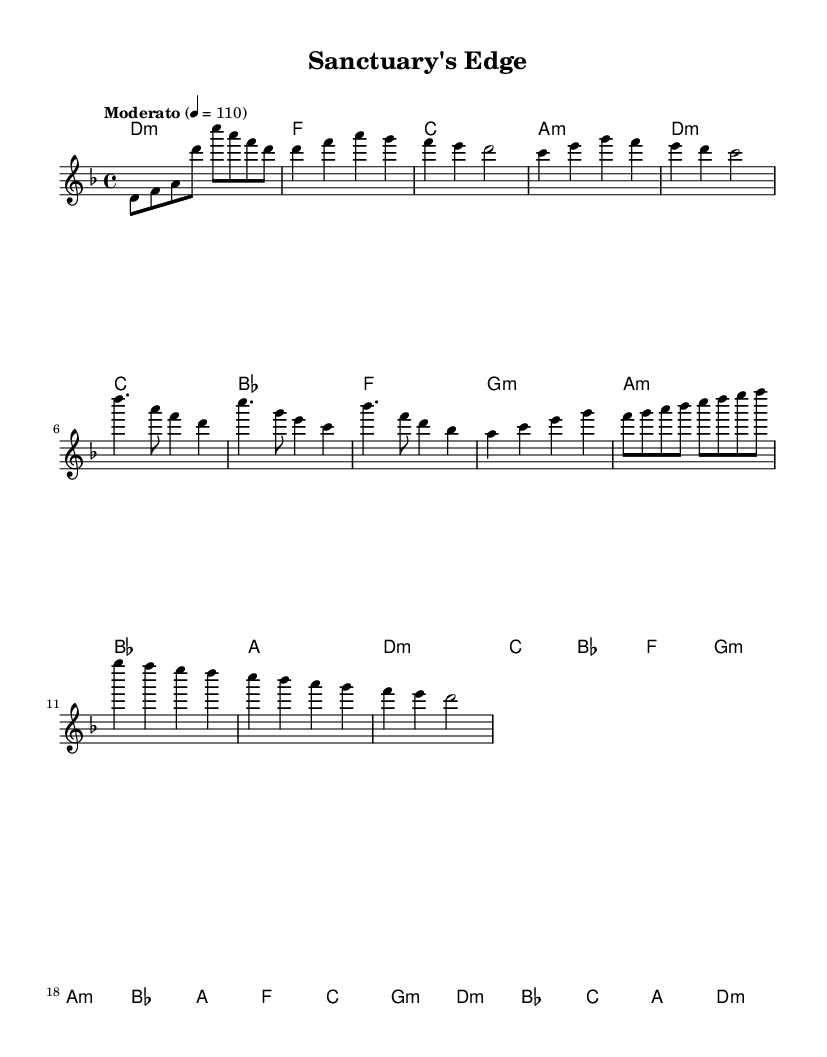What is the key signature of this music? The key signature is marked as D minor, which has one flat (B flat). This is indicated at the beginning of the staff where the key signature is located.
Answer: D minor What is the time signature of the piece? The time signature is 4/4, which is communicated through the notation at the beginning of the sheet music. This indicates that there are four beats per measure, with the quarter note receiving one beat.
Answer: 4/4 What is the tempo marking for this music? The tempo marking is indicated as "Moderato" with a metronome marking of 110 BPM, suggesting a moderate pace. This is written above the staff.
Answer: Moderato 110 How many distinct sections are present in the piece? By analyzing the structure, we notice the piece contains four main sections: Intro, Verse, Chorus, and Bridge. Each section is clearly defined in the sheet music layout.
Answer: Four What is the first chord in the piece? The first chord is written in the harmonies section directly below the first measure and it is a D minor chord. This is determined by identifying the chord symbol notation in that specific position.
Answer: D minor What is the last note of the melody? The last note of the melody is a D, as indicated by the final note in the melody line, positioned in the last measure. This reveals that the melody concludes on the tonic note.
Answer: D Which section contains the most complex chords? The Bridge section includes more varied chord progressions such as D minor, G minor, and B flat, which introduces more complexity compared to other sections. Analysis of chord types reveals this variety within the Bridge, compared to the more straightforward harmonies in the Verse and Chorus.
Answer: Bridge 